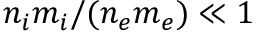Convert formula to latex. <formula><loc_0><loc_0><loc_500><loc_500>n _ { i } m _ { i } / ( n _ { e } m _ { e } ) \ll 1</formula> 